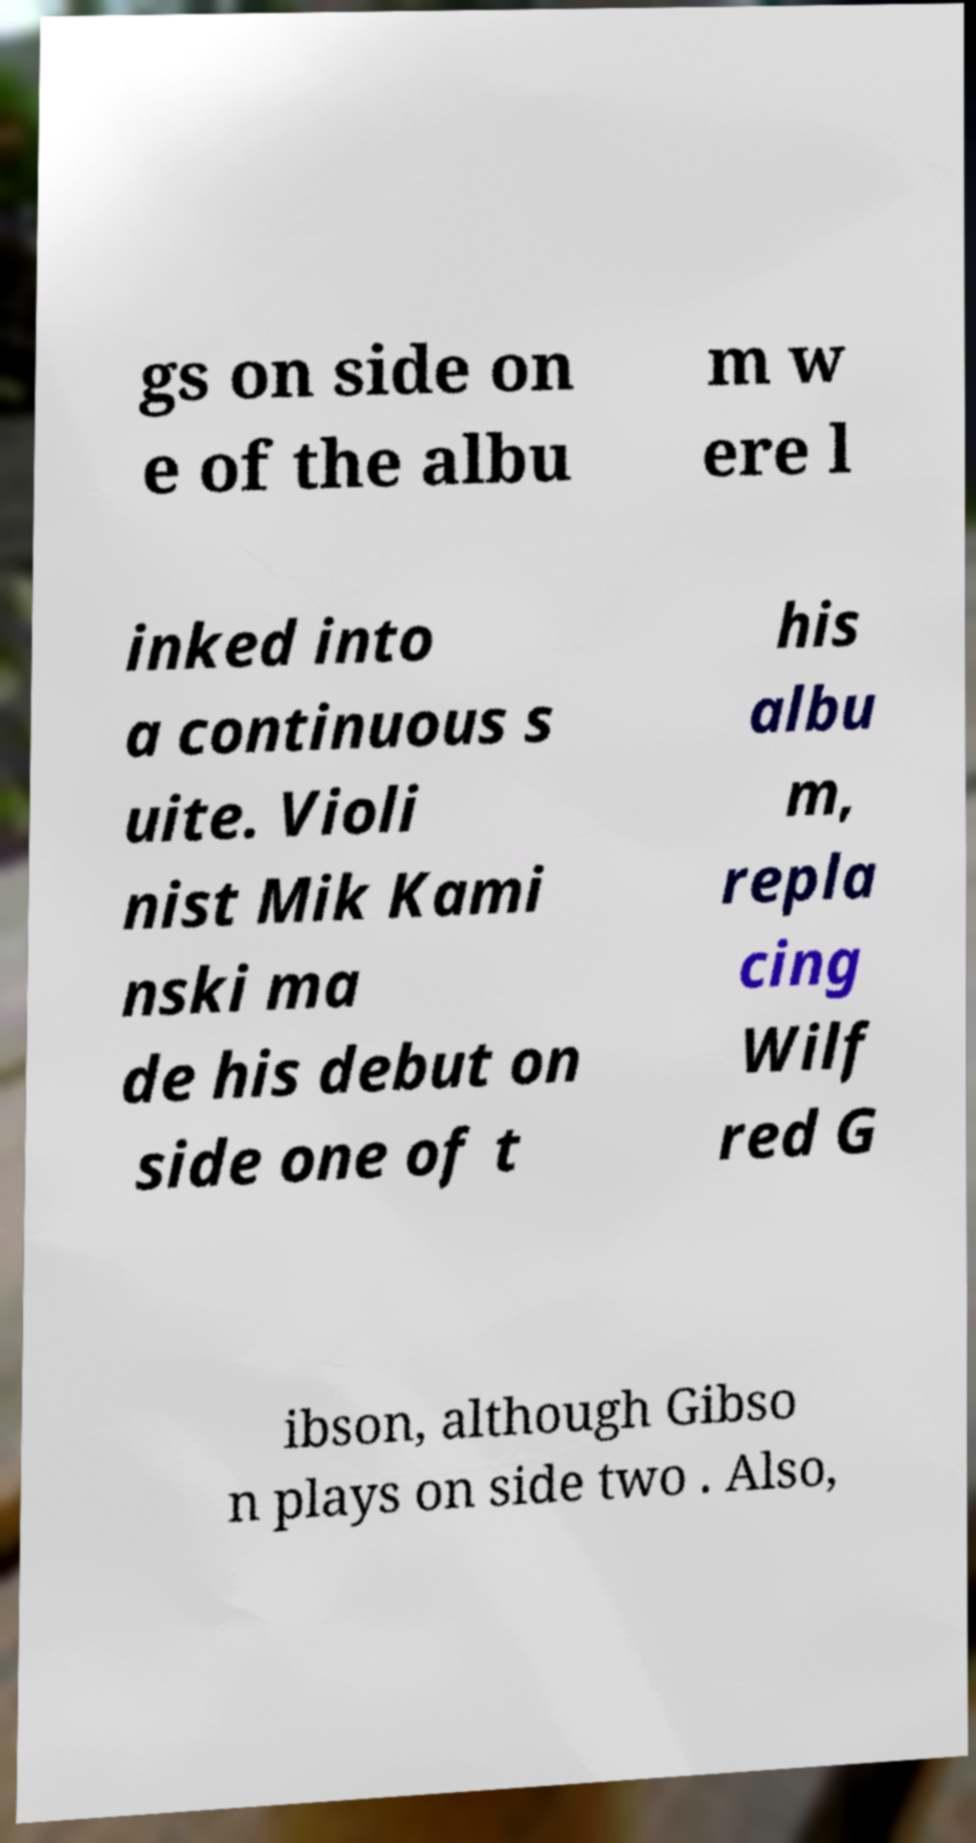Please read and relay the text visible in this image. What does it say? gs on side on e of the albu m w ere l inked into a continuous s uite. Violi nist Mik Kami nski ma de his debut on side one of t his albu m, repla cing Wilf red G ibson, although Gibso n plays on side two . Also, 